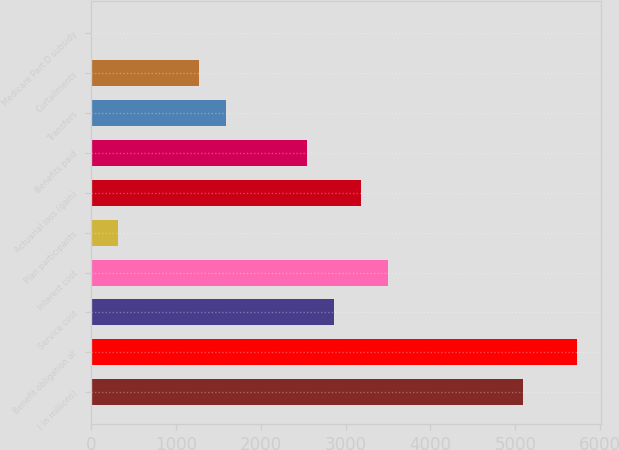Convert chart to OTSL. <chart><loc_0><loc_0><loc_500><loc_500><bar_chart><fcel>( in millions)<fcel>Benefit obligation at<fcel>Service cost<fcel>Interest cost<fcel>Plan participants<fcel>Actuarial loss (gain)<fcel>Benefits paid<fcel>Transfers<fcel>Curtailments<fcel>Medicare Part D subsidy<nl><fcel>5090.82<fcel>5726.74<fcel>2865.05<fcel>3500.99<fcel>321.32<fcel>3183.02<fcel>2547.08<fcel>1593.18<fcel>1275.22<fcel>3.35<nl></chart> 